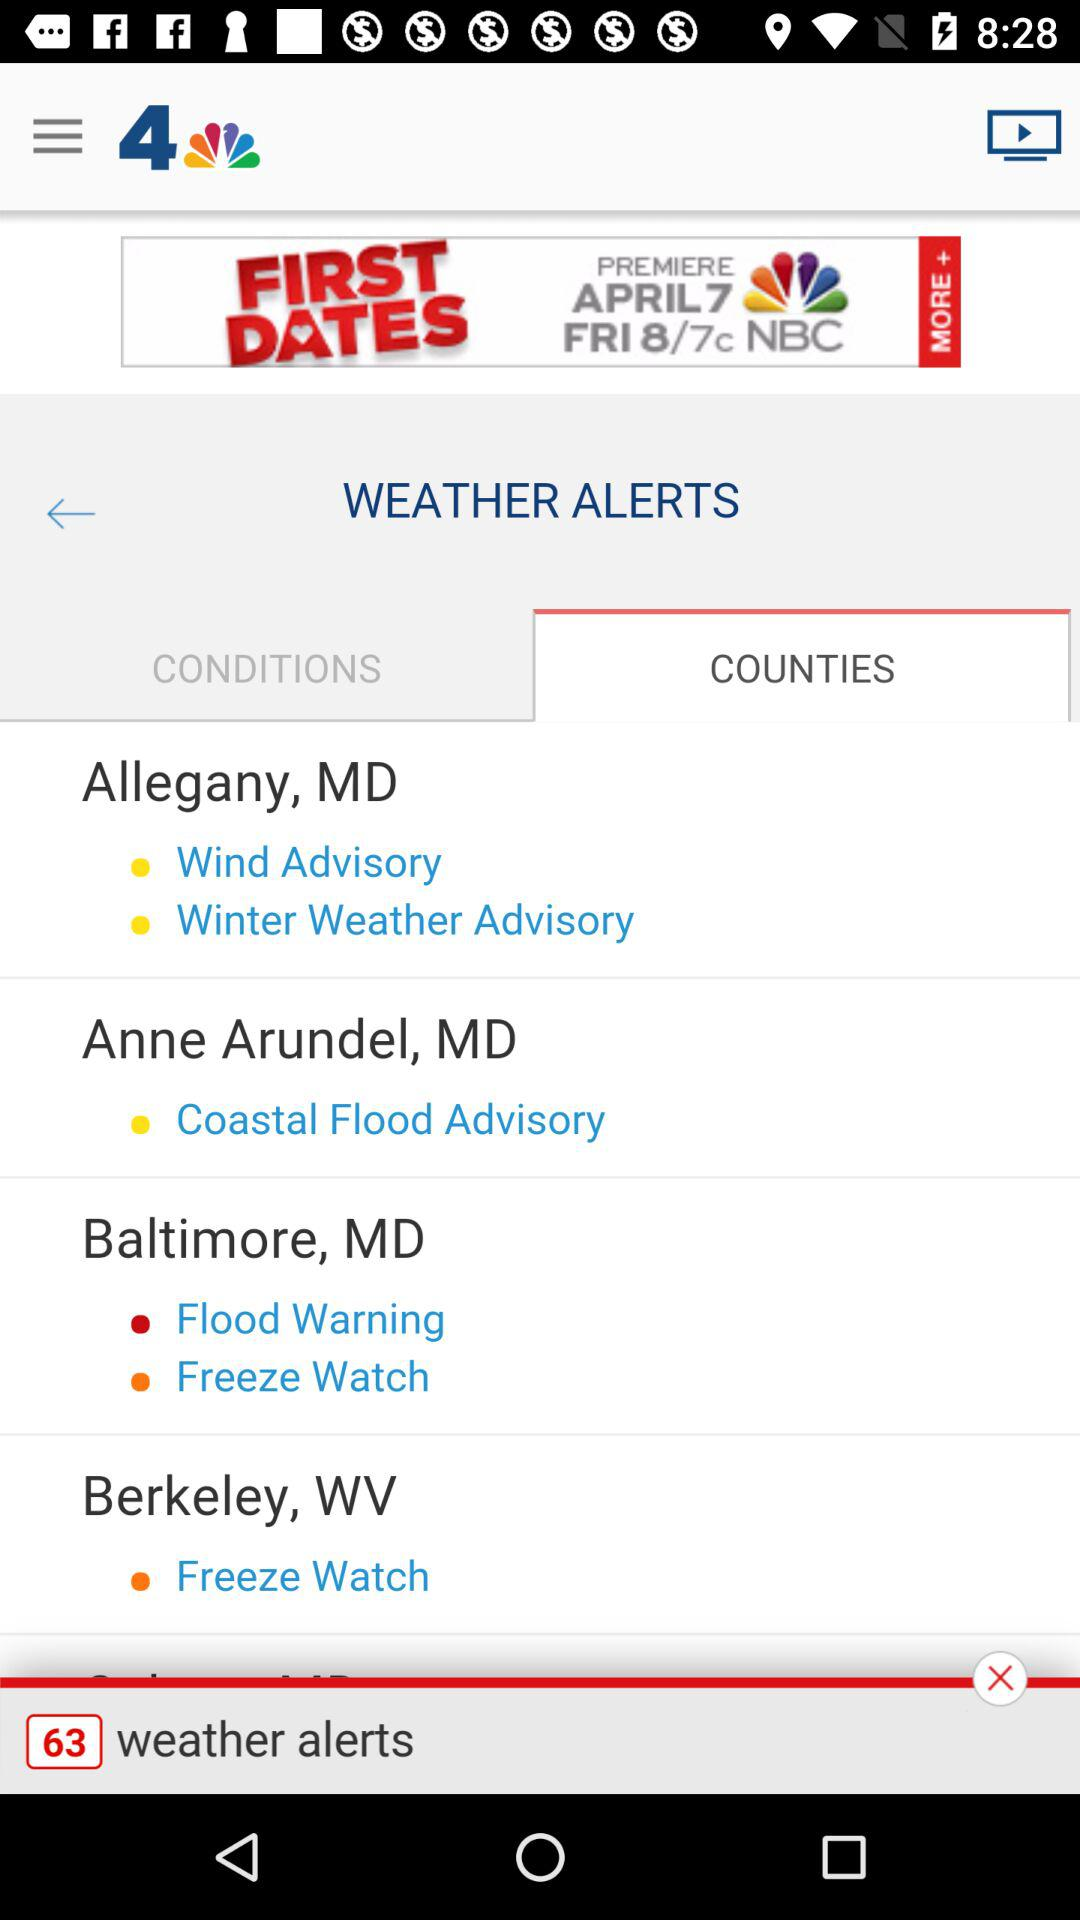How many counties have weather alerts?
Answer the question using a single word or phrase. 4 